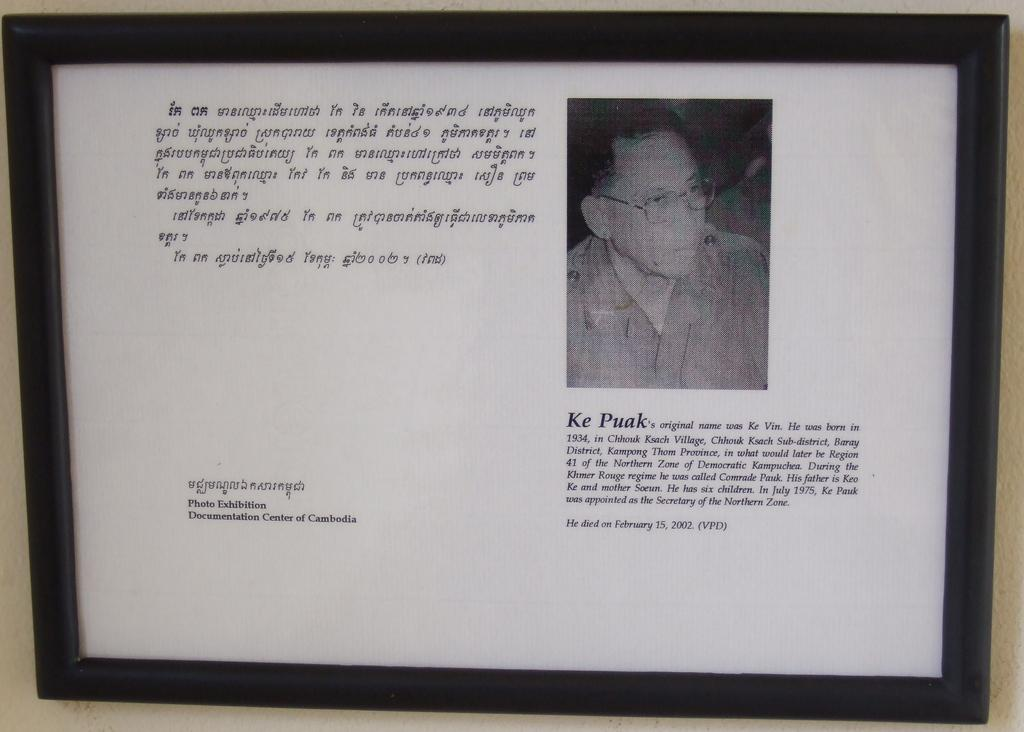<image>
Describe the image concisely. A picture frame hangs on a wall with a picture of a man name Ke Puak. 